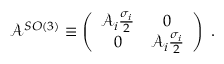Convert formula to latex. <formula><loc_0><loc_0><loc_500><loc_500>\mathcal { A } ^ { S O ( 3 ) } \equiv \left ( \begin{array} { c c } { { \mathcal { A } _ { i } \frac { \sigma _ { i } } { 2 } } } & { 0 } \\ { 0 } & { { \mathcal { A } _ { i } \frac { \sigma _ { i } } { 2 } } } \end{array} \right ) \, .</formula> 